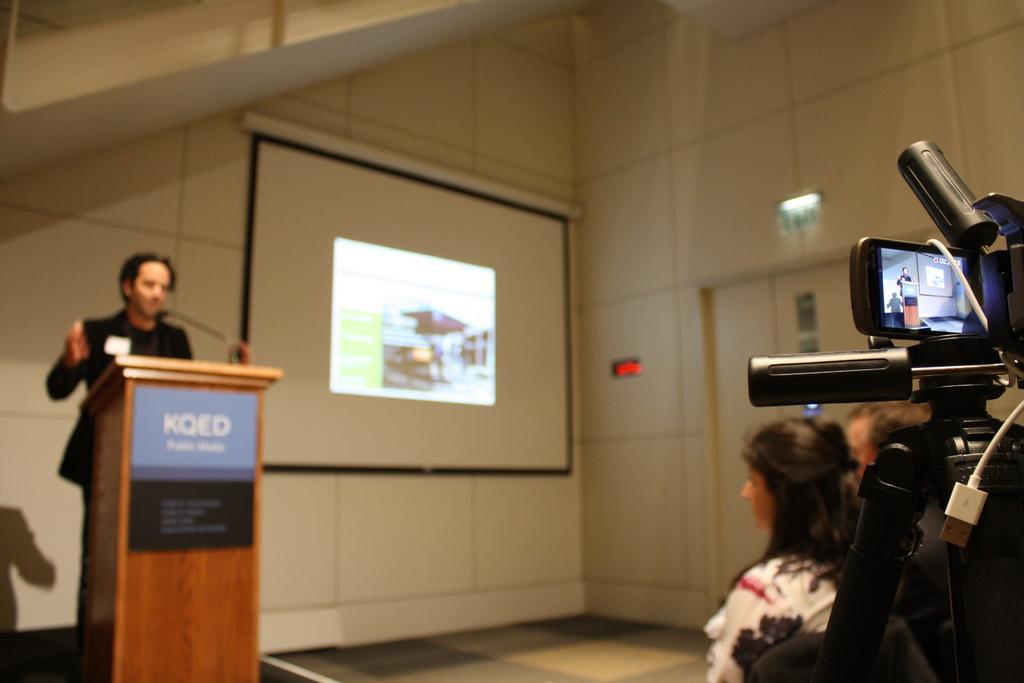In one or two sentences, can you explain what this image depicts? This image is taken indoors. On the right side of the image a man is standing on the dais behind a podium. In the background there is a wall with a projector screen. On the right side of the image a few people are standing on the floor and there is a camera on the camera stand. 